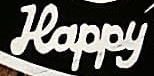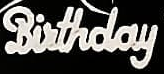What text appears in these images from left to right, separated by a semicolon? Happy; Birthday 